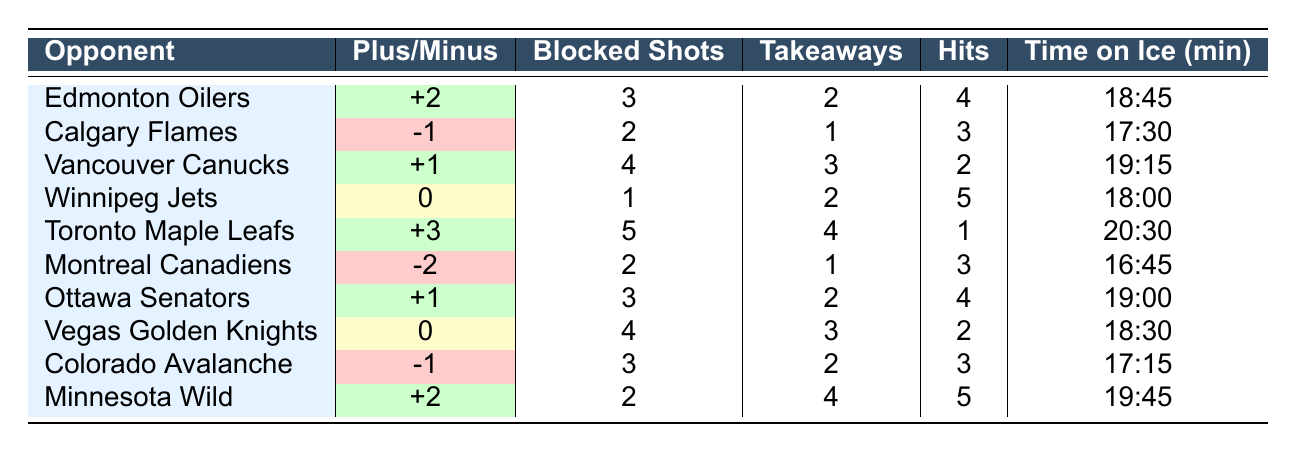What was Ryker Evans's plus/minus rating against the Toronto Maple Leafs? The table shows that Ryker Evans had a plus/minus rating of +3 against the Toronto Maple Leafs.
Answer: +3 How many blocked shots did Ryker Evans make against the Calgary Flames? The table indicates that he made 2 blocked shots against the Calgary Flames.
Answer: 2 Did Ryker Evans have a positive plus/minus rating in the game against the Edmonton Oilers? The table states that his plus/minus rating was +2 against the Edmonton Oilers, which is positive.
Answer: Yes What is the average time on ice for Ryker Evans across all opponents? To find the average time on ice, convert all times to minutes: 18.75, 17.5, 19.25, 18, 20.5, 16.75, 19, 18.5, 17.25, 19.75. The average is calculated (18.75 + 17.5 + 19.25 + 18 + 20.5 + 16.75 + 19 + 18.5 + 17.25 + 19.75) / 10 = 18.325 minutes.
Answer: 18.33 minutes Against which opponent did Ryker Evans achieve his highest number of takeaways? Analyzing the takeaways column reveals that he had 4 takeaways against the Toronto Maple Leafs, which is the highest among all opponents.
Answer: Toronto Maple Leafs How many total hits did Ryker Evans record in games where he had a positive plus/minus rating? From the table, he had positive ratings (+2, +1, +3, +1, +2). The corresponding hits are 4, 2, 1, 4, and 5, respectively. Summing those hits gives 16 (4 + 2 + 1 + 4 + 5 = 16).
Answer: 16 Was there a game where Ryker Evans had no blocked shots? Checking the blocked shots column, it shows that there are no instances where he had zero blocked shots in any game listed.
Answer: No Which opponent had the lowest plus/minus rating for Ryker Evans? By examining the plus/minus column, the Montreal Canadiens had the lowest rating at -2, which is the most negative rating listed.
Answer: Montreal Canadiens How does Ryker Evans's total blocked shots compare between the Edmonton Oilers and the Winnipeg Jets? The table shows he had 3 blocked shots against the Edmonton Oilers and 1 against the Winnipeg Jets. Thus, he had 2 more blocked shots against the Oilers.
Answer: He had 2 more against the Oilers What is the difference in plus/minus rating between the game against the Calgary Flames and the Minnesota Wild? The plus/minus rating against Calgary Flames is -1 and against Minnesota Wild is +2. The difference is 2 - (-1) = 3.
Answer: 3 In how many games did Ryker Evans have a positive plus/minus rating while also recording at least 3 blocked shots? He had positive ratings and at least 3 blocked shots in games against the Edmonton Oilers, Toronto Maple Leafs, and Ottawa Senators. This totals 3 games.
Answer: 3 